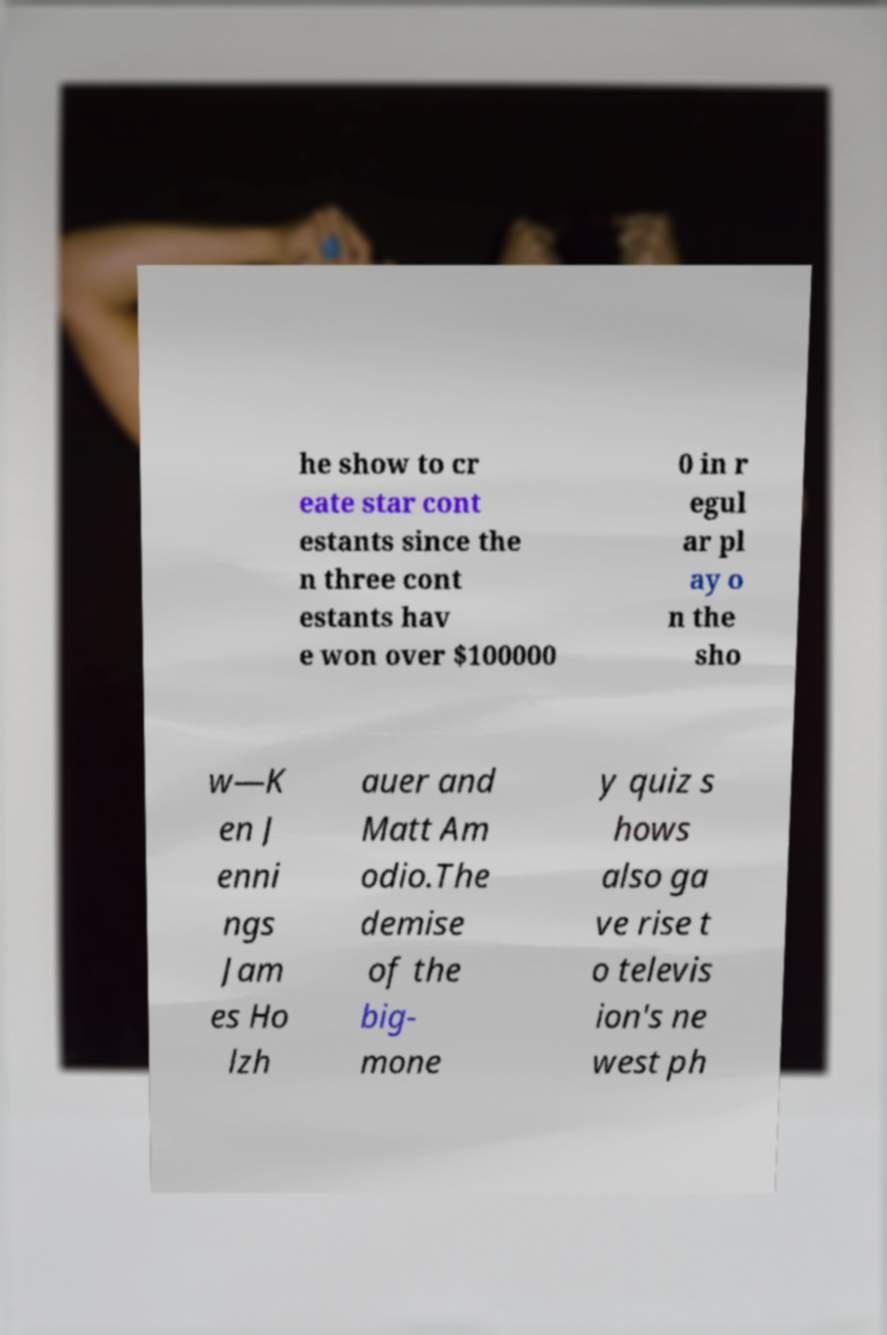Can you accurately transcribe the text from the provided image for me? he show to cr eate star cont estants since the n three cont estants hav e won over $100000 0 in r egul ar pl ay o n the sho w—K en J enni ngs Jam es Ho lzh auer and Matt Am odio.The demise of the big- mone y quiz s hows also ga ve rise t o televis ion's ne west ph 